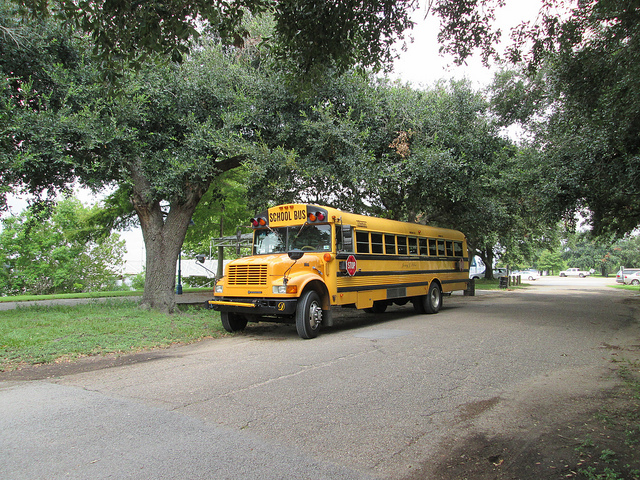Please extract the text content from this image. SCHOOL BUS stop 